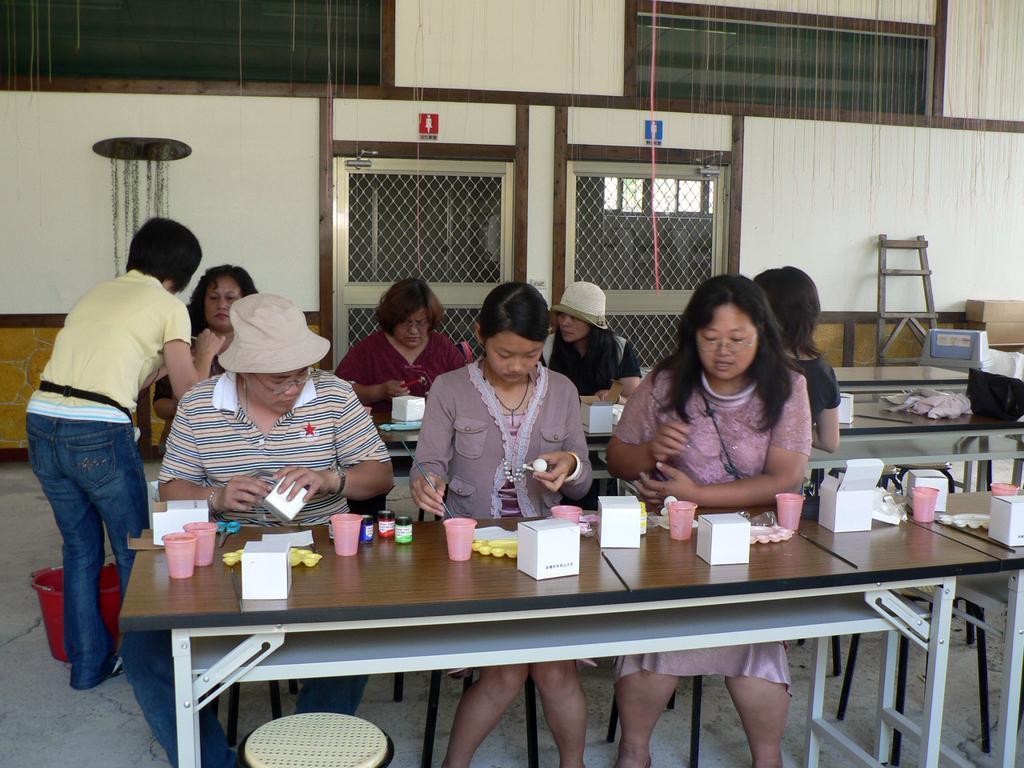Could you give a brief overview of what you see in this image? There is a group of people who are sitting. They are working. 